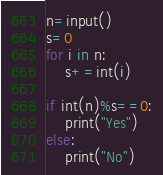Convert code to text. <code><loc_0><loc_0><loc_500><loc_500><_Python_>n=input()
s=0
for i in n:
    s+=int(i)

if int(n)%s==0:
    print("Yes")
else:
    print("No")
</code> 